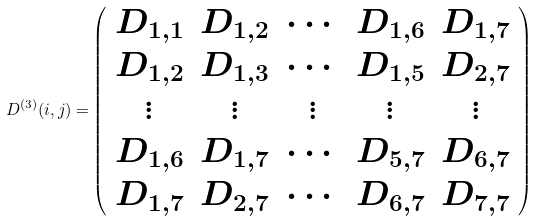<formula> <loc_0><loc_0><loc_500><loc_500>D ^ { ( 3 ) } { ( i , j ) = } \left ( \begin{array} { c c c c c } D _ { 1 , 1 } & D _ { 1 , 2 } & \cdots & D _ { 1 , 6 } & D _ { 1 , 7 } \\ D _ { 1 , 2 } & D _ { 1 , 3 } & \cdots & D _ { 1 , 5 } & D _ { 2 , 7 } \\ \vdots & \vdots & \vdots & \vdots & \vdots \\ D _ { 1 , 6 } & D _ { 1 , 7 } & \cdots & D _ { 5 , 7 } & D _ { 6 , 7 } \\ D _ { 1 , 7 } & D _ { 2 , 7 } & \cdots & D _ { 6 , 7 } & D _ { 7 , 7 } \end{array} \right )</formula> 